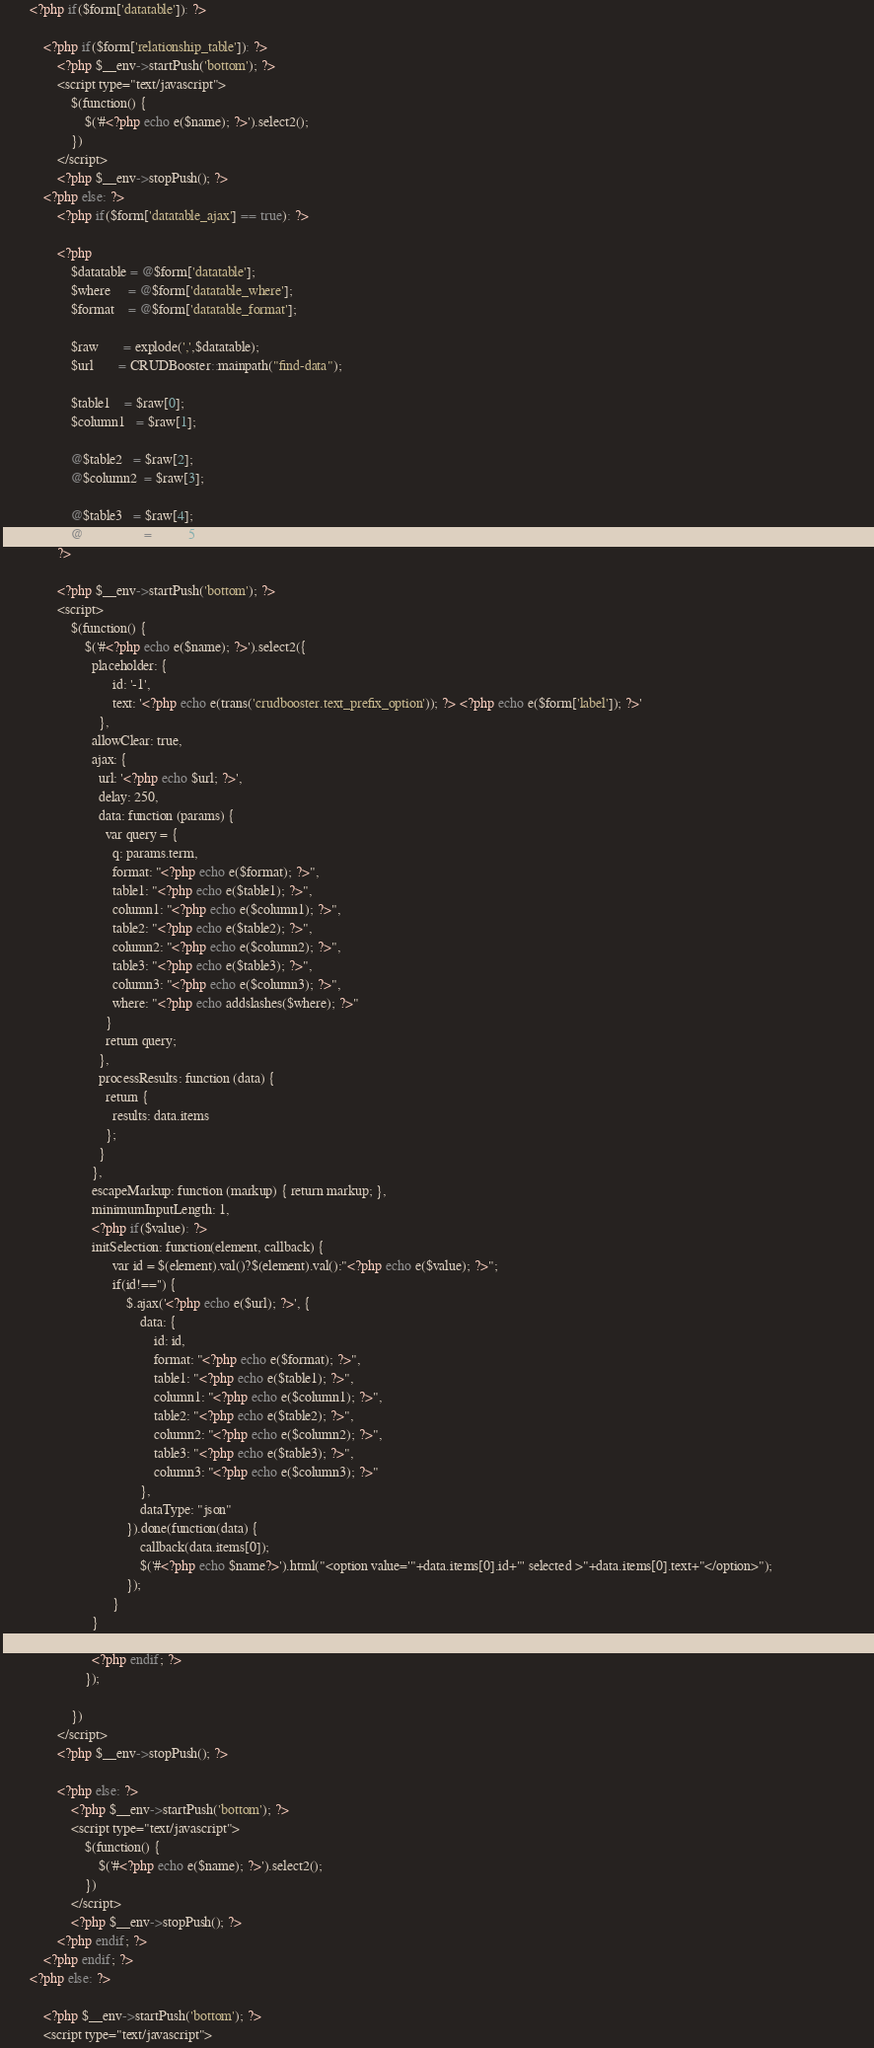Convert code to text. <code><loc_0><loc_0><loc_500><loc_500><_PHP_>
		<?php if($form['datatable']): ?>

			<?php if($form['relationship_table']): ?>
				<?php $__env->startPush('bottom'); ?>
				<script type="text/javascript">
					$(function() {
						$('#<?php echo e($name); ?>').select2();
					})
				</script>
				<?php $__env->stopPush(); ?>
			<?php else: ?>
				<?php if($form['datatable_ajax'] == true): ?>

				<?php 							
					$datatable = @$form['datatable'];
					$where     = @$form['datatable_where'];
					$format    = @$form['datatable_format'];													

					$raw       = explode(',',$datatable);
					$url       = CRUDBooster::mainpath("find-data");

					$table1    = $raw[0];
					$column1   = $raw[1];
					
					@$table2   = $raw[2];
					@$column2  = $raw[3];
					
					@$table3   = $raw[4];
					@$column3  = $raw[5];
				?>

				<?php $__env->startPush('bottom'); ?>
				<script>				
					$(function() {
						$('#<?php echo e($name); ?>').select2({								  							  
						  placeholder: {
							    id: '-1', 
							    text: '<?php echo e(trans('crudbooster.text_prefix_option')); ?> <?php echo e($form['label']); ?>'
							},
						  allowClear: true,
						  ajax: {								  	
						    url: '<?php echo $url; ?>',								    
						    delay: 250,								   								    
						    data: function (params) {
						      var query = {
								q: params.term,
								format: "<?php echo e($format); ?>",
								table1: "<?php echo e($table1); ?>",
								column1: "<?php echo e($column1); ?>",
								table2: "<?php echo e($table2); ?>",
								column2: "<?php echo e($column2); ?>",
								table3: "<?php echo e($table3); ?>",
								column3: "<?php echo e($column3); ?>",
								where: "<?php echo addslashes($where); ?>"
						      }
						      return query;
						    },
						    processResults: function (data) {
						      return {
						        results: data.items
						      };
						    }								    								    
						  },
						  escapeMarkup: function (markup) { return markup; }, 							        							    
						  minimumInputLength: 1,
					      <?php if($value): ?>
						  initSelection: function(element, callback) {
					            var id = $(element).val()?$(element).val():"<?php echo e($value); ?>";
					            if(id!=='') {
					                $.ajax('<?php echo e($url); ?>', {
					                    data: {
					                    	id: id, 
					                    	format: "<?php echo e($format); ?>",
					                    	table1: "<?php echo e($table1); ?>",
											column1: "<?php echo e($column1); ?>",
											table2: "<?php echo e($table2); ?>",
											column2: "<?php echo e($column2); ?>",
											table3: "<?php echo e($table3); ?>",
											column3: "<?php echo e($column3); ?>"
										},
					                    dataType: "json"
					                }).done(function(data) {							                	
					                    callback(data.items[0]);	
					                    $('#<?php echo $name?>').html("<option value='"+data.items[0].id+"' selected >"+data.items[0].text+"</option>");			                	
					                });
					            }
					      }
				
					      <?php endif; ?>							      
						});

					})
				</script>
				<?php $__env->stopPush(); ?>

				<?php else: ?>
					<?php $__env->startPush('bottom'); ?>
					<script type="text/javascript">
						$(function() {
							$('#<?php echo e($name); ?>').select2();
						})
					</script>
					<?php $__env->stopPush(); ?>
				<?php endif; ?>
			<?php endif; ?>
		<?php else: ?>

			<?php $__env->startPush('bottom'); ?>
			<script type="text/javascript"></code> 